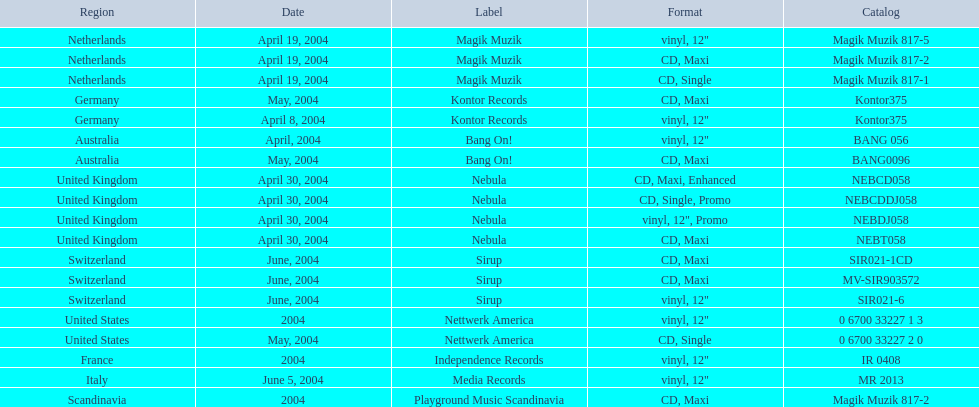What are the labels for love comes again? Magik Muzik, Magik Muzik, Magik Muzik, Kontor Records, Kontor Records, Bang On!, Bang On!, Nebula, Nebula, Nebula, Nebula, Sirup, Sirup, Sirup, Nettwerk America, Nettwerk America, Independence Records, Media Records, Playground Music Scandinavia. What label has been used by the region of france? Independence Records. What are the various labels for "love comes again"? Magik Muzik, Magik Muzik, Magik Muzik, Kontor Records, Kontor Records, Bang On!, Bang On!, Nebula, Nebula, Nebula, Nebula, Sirup, Sirup, Sirup, Nettwerk America, Nettwerk America, Independence Records, Media Records, Playground Music Scandinavia. What is the label employed by the region in france? Independence Records. 